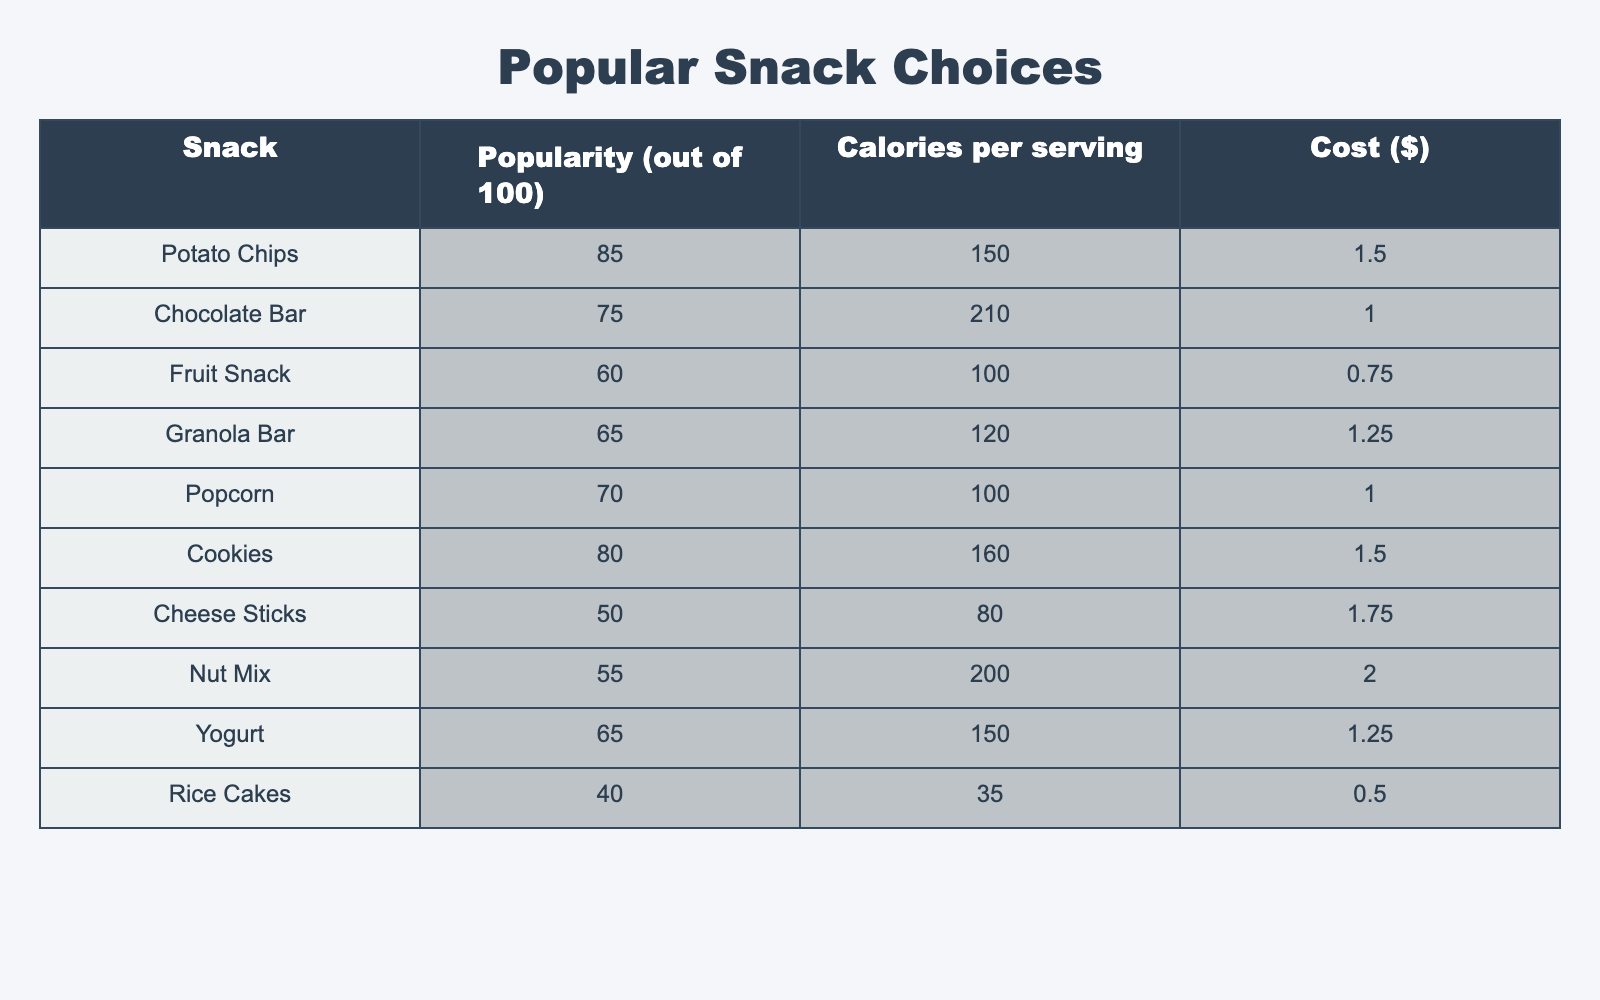What is the most popular snack among students? Looking at the "Popularity" column, Potato Chips have the highest score of 85 out of 100, which makes them the most popular snack.
Answer: Potato Chips What snack has the least calories per serving? In the "Calories per serving" column, Rice Cakes have the lowest value of 35 calories per serving, which is the least among all options.
Answer: Rice Cakes How many calories do cookies contain? Referring to the "Calories per serving" column, Cookies contain 160 calories per serving.
Answer: 160 What is the average popularity of all snacks? Add the popularity scores: 85 + 75 + 60 + 65 + 70 + 80 + 50 + 55 + 65 + 40 =  75. The number of snacks is 10, so average popularity = 750 / 10 = 75.
Answer: 75 Which snack is cheaper than $1.25? Looking at the "Cost" column, both Fruit Snack ($0.75) and Popcorn ($1.00) are cheaper than $1.25.
Answer: Fruit Snack, Popcorn Is the average calorie content of cheese sticks higher than that of yogurt? Cheese Sticks have 80 calories, and Yogurt has 150 calories. Since 80 < 150, Cheese Sticks' average calorie content is not higher than Yogurt's.
Answer: No What snack has a popularity score of 60 or lower? Checking the "Popularity" column, both Fruit Snack (60) and Cheese Sticks (50) have scores of 60 or lower, hence these are the snacks that qualify.
Answer: Fruit Snack, Cheese Sticks Calculate the difference in popularity between Granola Bar and Chocolate Bar. Granola Bar has a popularity of 65 and Chocolate Bar a score of 75. The difference is 75 - 65 = 10.
Answer: 10 Which snacks cost more than $1.50? In the "Cost" column, only Nut Mix has a cost of $2.00, which is greater than $1.50.
Answer: Nut Mix What is the total cost for purchasing one serving of each snack? Summing the cost of all snacks: 1.50 + 1.00 + 0.75 + 1.25 + 1.00 + 1.50 + 1.75 + 2.00 + 1.25 + 0.50 = 12.75.
Answer: 12.75 